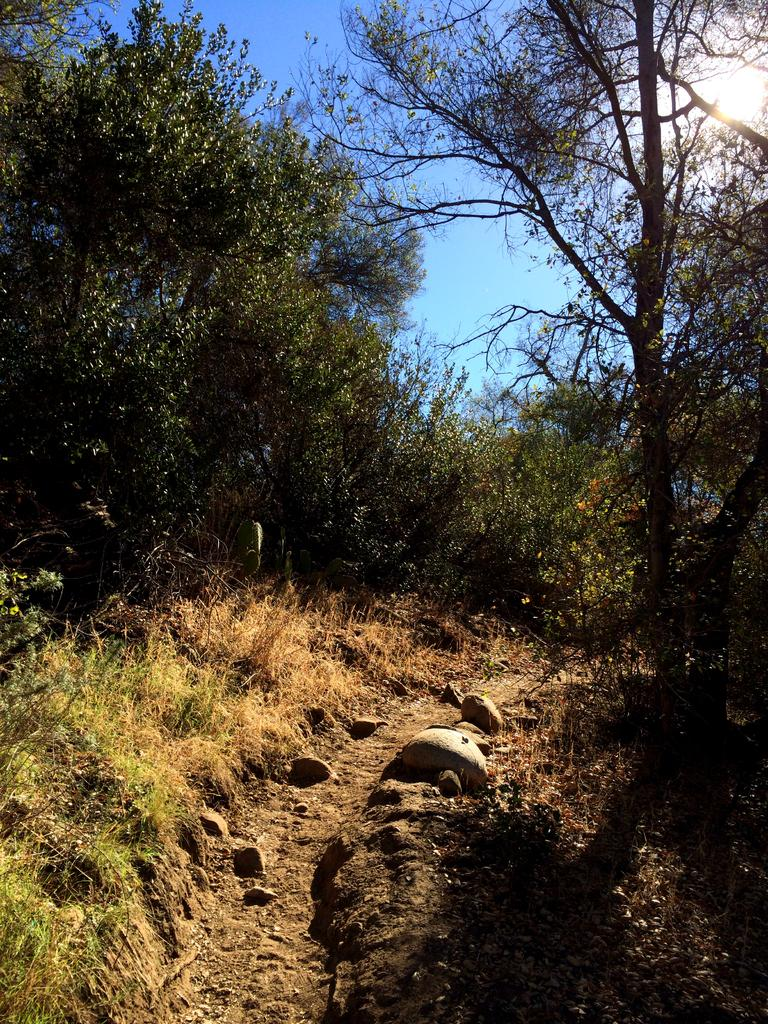What type of terrain is depicted in the image? There are rocks and grass on the ground in the image. What can be seen in the background of the image? There are many trees and clouds visible in the background of the image. What part of the natural environment is visible in the image? The sky is visible in the background of the image. What type of tin can be seen in the image? There is no tin present in the image. What thoughts are being expressed by the trees in the image? Trees do not have thoughts, so this cannot be answered. 